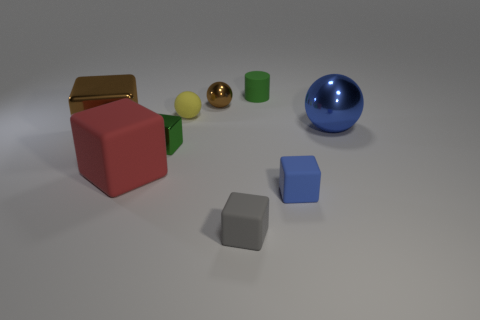Subtract all gray cubes. How many cubes are left? 4 Subtract all brown blocks. How many blocks are left? 4 Subtract all yellow spheres. Subtract all blue cylinders. How many spheres are left? 2 Add 1 gray metal objects. How many objects exist? 10 Subtract all balls. How many objects are left? 6 Add 7 tiny gray matte cubes. How many tiny gray matte cubes exist? 8 Subtract 1 brown blocks. How many objects are left? 8 Subtract all big yellow cylinders. Subtract all yellow things. How many objects are left? 8 Add 5 big red rubber cubes. How many big red rubber cubes are left? 6 